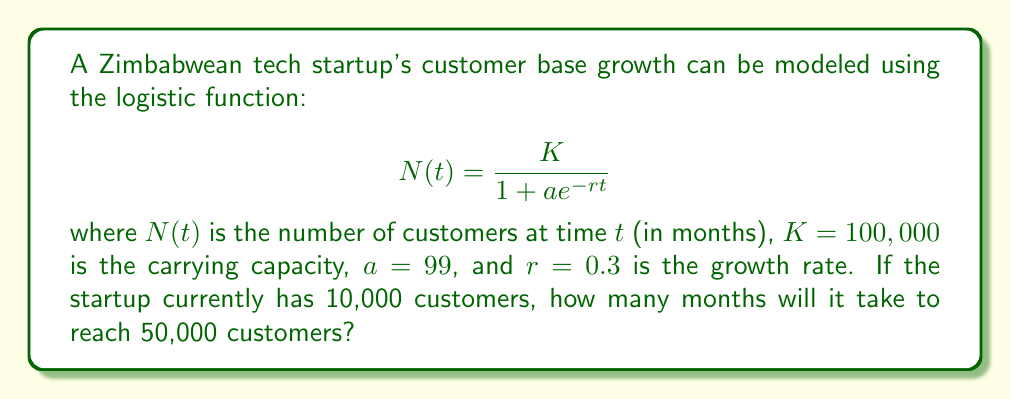Show me your answer to this math problem. Let's approach this step-by-step:

1) We need to solve the equation:

   $$50,000 = \frac{100,000}{1 + 99e^{-0.3t}}$$

2) Simplify the left side:

   $$\frac{1}{2} = \frac{1}{1 + 99e^{-0.3t}}$$

3) Take the reciprocal of both sides:

   $$2 = 1 + 99e^{-0.3t}$$

4) Subtract 1 from both sides:

   $$1 = 99e^{-0.3t}$$

5) Divide both sides by 99:

   $$\frac{1}{99} = e^{-0.3t}$$

6) Take the natural log of both sides:

   $$\ln(\frac{1}{99}) = -0.3t$$

7) Divide both sides by -0.3:

   $$\frac{\ln(\frac{1}{99})}{-0.3} = t$$

8) Simplify:

   $$\frac{\ln(99)}{0.3} = t$$

9) Calculate the result:

   $$t \approx 15.39$$

10) Since we're dealing with months, we round up to the nearest whole number.
Answer: 16 months 